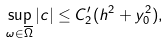Convert formula to latex. <formula><loc_0><loc_0><loc_500><loc_500>\sup _ { \omega \in \overline { \Omega } } | c | \leq C _ { 2 } ^ { \prime } ( h ^ { 2 } + y _ { 0 } ^ { 2 } ) ,</formula> 